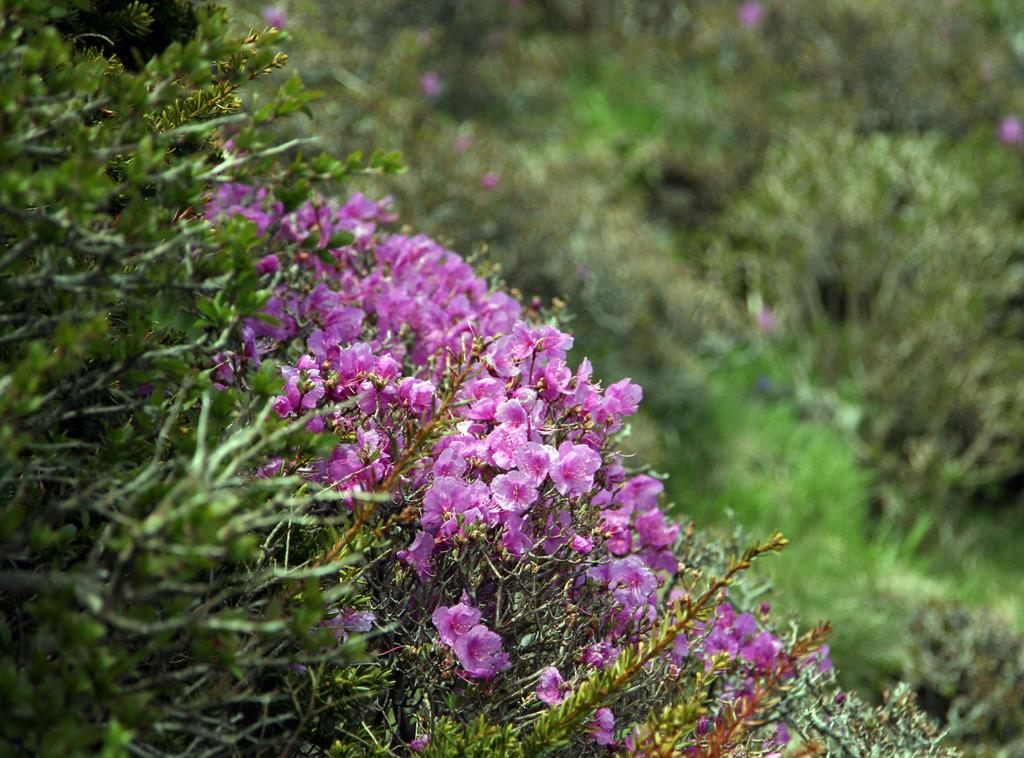What type of living organisms are in the image? There are plants in the image. What color are the flowers on the plants? The flowers on the plants are pink. Can you describe the background of the image? The background of the image is blurred. What type of recess can be seen in the image? There is no recess present in the image; it features plants with pink flowers. What is the ground made of in the image? The ground is not visible in the image, as it is focused on the plants with pink flowers. 